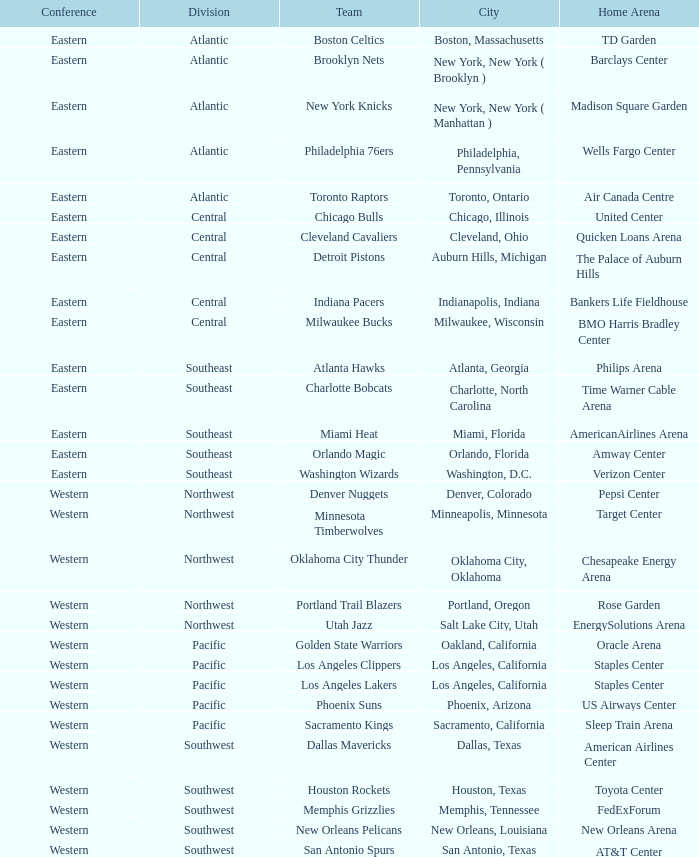In which segment do the toronto raptors participate? Atlantic. Can you give me this table as a dict? {'header': ['Conference', 'Division', 'Team', 'City', 'Home Arena'], 'rows': [['Eastern', 'Atlantic', 'Boston Celtics', 'Boston, Massachusetts', 'TD Garden'], ['Eastern', 'Atlantic', 'Brooklyn Nets', 'New York, New York ( Brooklyn )', 'Barclays Center'], ['Eastern', 'Atlantic', 'New York Knicks', 'New York, New York ( Manhattan )', 'Madison Square Garden'], ['Eastern', 'Atlantic', 'Philadelphia 76ers', 'Philadelphia, Pennsylvania', 'Wells Fargo Center'], ['Eastern', 'Atlantic', 'Toronto Raptors', 'Toronto, Ontario', 'Air Canada Centre'], ['Eastern', 'Central', 'Chicago Bulls', 'Chicago, Illinois', 'United Center'], ['Eastern', 'Central', 'Cleveland Cavaliers', 'Cleveland, Ohio', 'Quicken Loans Arena'], ['Eastern', 'Central', 'Detroit Pistons', 'Auburn Hills, Michigan', 'The Palace of Auburn Hills'], ['Eastern', 'Central', 'Indiana Pacers', 'Indianapolis, Indiana', 'Bankers Life Fieldhouse'], ['Eastern', 'Central', 'Milwaukee Bucks', 'Milwaukee, Wisconsin', 'BMO Harris Bradley Center'], ['Eastern', 'Southeast', 'Atlanta Hawks', 'Atlanta, Georgia', 'Philips Arena'], ['Eastern', 'Southeast', 'Charlotte Bobcats', 'Charlotte, North Carolina', 'Time Warner Cable Arena'], ['Eastern', 'Southeast', 'Miami Heat', 'Miami, Florida', 'AmericanAirlines Arena'], ['Eastern', 'Southeast', 'Orlando Magic', 'Orlando, Florida', 'Amway Center'], ['Eastern', 'Southeast', 'Washington Wizards', 'Washington, D.C.', 'Verizon Center'], ['Western', 'Northwest', 'Denver Nuggets', 'Denver, Colorado', 'Pepsi Center'], ['Western', 'Northwest', 'Minnesota Timberwolves', 'Minneapolis, Minnesota', 'Target Center'], ['Western', 'Northwest', 'Oklahoma City Thunder', 'Oklahoma City, Oklahoma', 'Chesapeake Energy Arena'], ['Western', 'Northwest', 'Portland Trail Blazers', 'Portland, Oregon', 'Rose Garden'], ['Western', 'Northwest', 'Utah Jazz', 'Salt Lake City, Utah', 'EnergySolutions Arena'], ['Western', 'Pacific', 'Golden State Warriors', 'Oakland, California', 'Oracle Arena'], ['Western', 'Pacific', 'Los Angeles Clippers', 'Los Angeles, California', 'Staples Center'], ['Western', 'Pacific', 'Los Angeles Lakers', 'Los Angeles, California', 'Staples Center'], ['Western', 'Pacific', 'Phoenix Suns', 'Phoenix, Arizona', 'US Airways Center'], ['Western', 'Pacific', 'Sacramento Kings', 'Sacramento, California', 'Sleep Train Arena'], ['Western', 'Southwest', 'Dallas Mavericks', 'Dallas, Texas', 'American Airlines Center'], ['Western', 'Southwest', 'Houston Rockets', 'Houston, Texas', 'Toyota Center'], ['Western', 'Southwest', 'Memphis Grizzlies', 'Memphis, Tennessee', 'FedExForum'], ['Western', 'Southwest', 'New Orleans Pelicans', 'New Orleans, Louisiana', 'New Orleans Arena'], ['Western', 'Southwest', 'San Antonio Spurs', 'San Antonio, Texas', 'AT&T Center']]} 